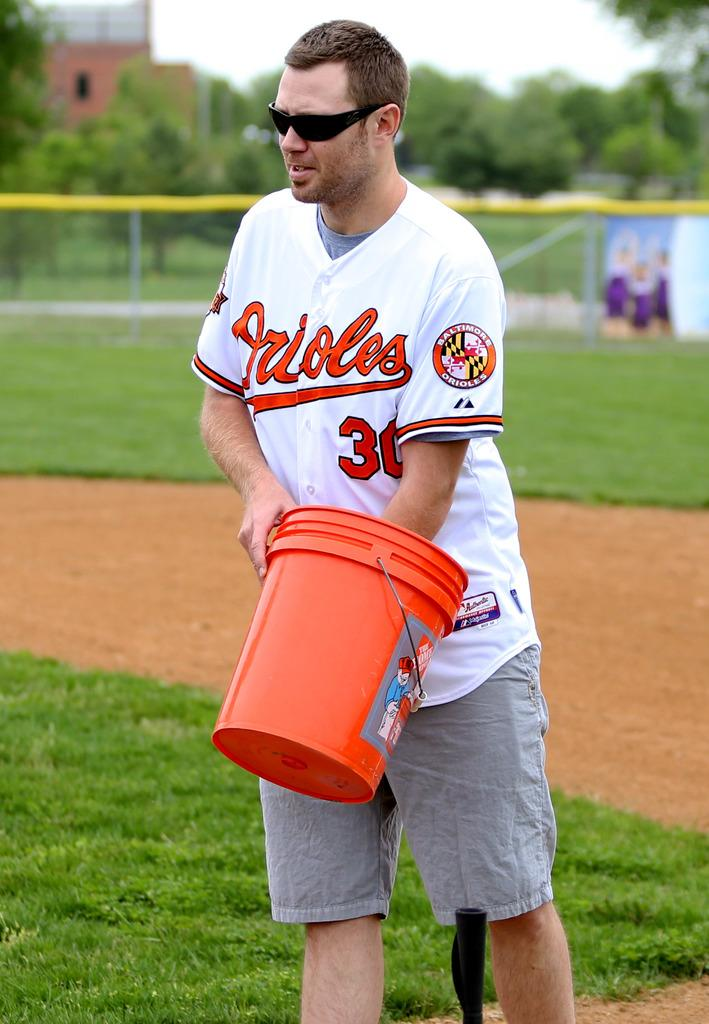<image>
Relay a brief, clear account of the picture shown. a person with an Orioles 30 jersey holds an orange bucket 